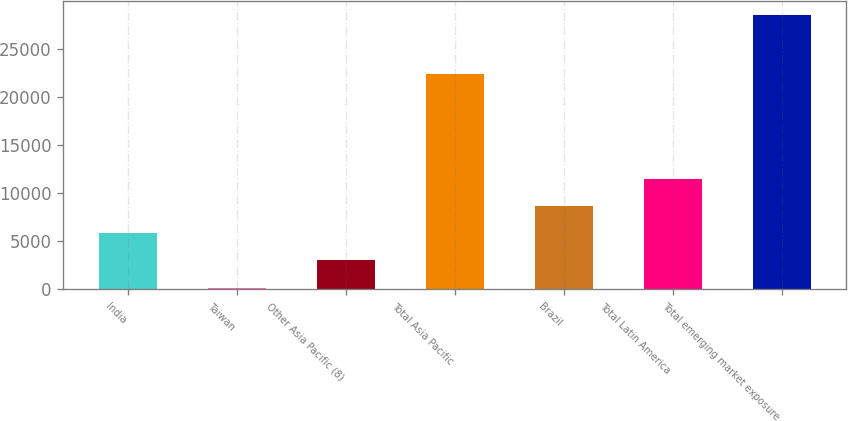Convert chart. <chart><loc_0><loc_0><loc_500><loc_500><bar_chart><fcel>India<fcel>Taiwan<fcel>Other Asia Pacific (8)<fcel>Total Asia Pacific<fcel>Brazil<fcel>Total Latin America<fcel>Total emerging market exposure<nl><fcel>5841<fcel>169<fcel>3005<fcel>22355<fcel>8677<fcel>11513<fcel>28529<nl></chart> 